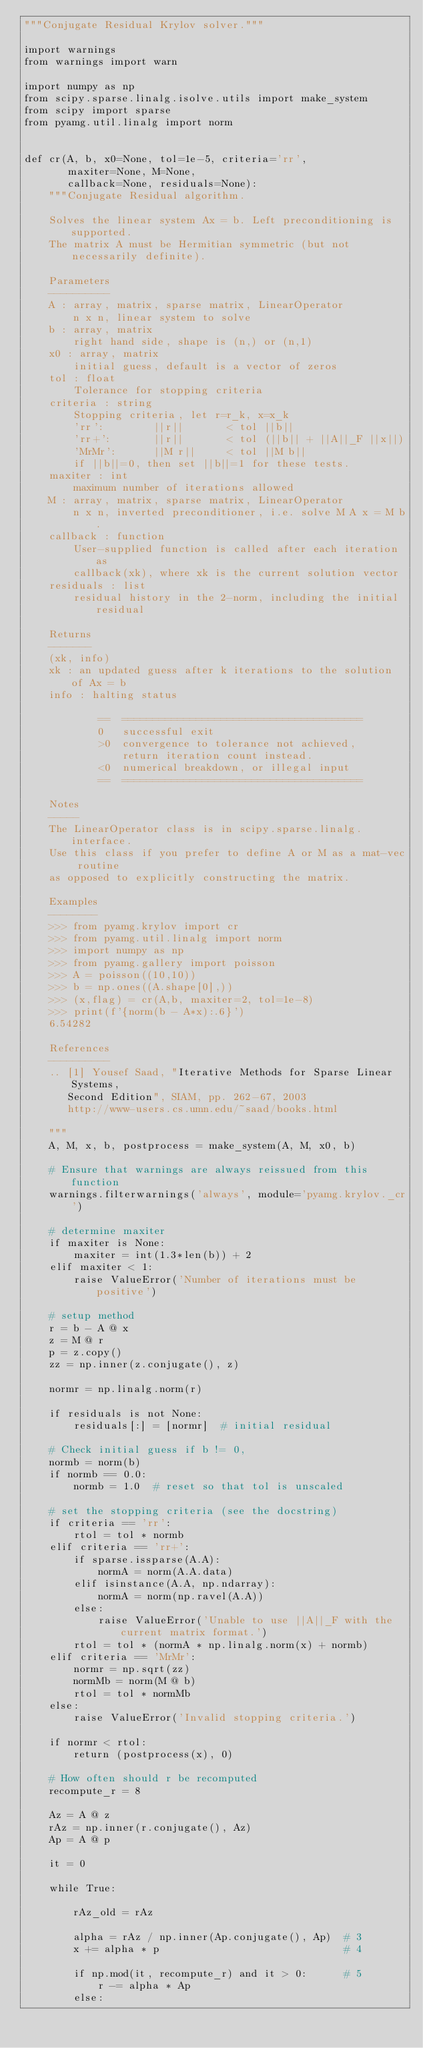Convert code to text. <code><loc_0><loc_0><loc_500><loc_500><_Python_>"""Conjugate Residual Krylov solver."""

import warnings
from warnings import warn

import numpy as np
from scipy.sparse.linalg.isolve.utils import make_system
from scipy import sparse
from pyamg.util.linalg import norm


def cr(A, b, x0=None, tol=1e-5, criteria='rr',
       maxiter=None, M=None,
       callback=None, residuals=None):
    """Conjugate Residual algorithm.

    Solves the linear system Ax = b. Left preconditioning is supported.
    The matrix A must be Hermitian symmetric (but not necessarily definite).

    Parameters
    ----------
    A : array, matrix, sparse matrix, LinearOperator
        n x n, linear system to solve
    b : array, matrix
        right hand side, shape is (n,) or (n,1)
    x0 : array, matrix
        initial guess, default is a vector of zeros
    tol : float
        Tolerance for stopping criteria
    criteria : string
        Stopping criteria, let r=r_k, x=x_k
        'rr':        ||r||       < tol ||b||
        'rr+':       ||r||       < tol (||b|| + ||A||_F ||x||)
        'MrMr':      ||M r||     < tol ||M b||
        if ||b||=0, then set ||b||=1 for these tests.
    maxiter : int
        maximum number of iterations allowed
    M : array, matrix, sparse matrix, LinearOperator
        n x n, inverted preconditioner, i.e. solve M A x = M b.
    callback : function
        User-supplied function is called after each iteration as
        callback(xk), where xk is the current solution vector
    residuals : list
        residual history in the 2-norm, including the initial residual

    Returns
    -------
    (xk, info)
    xk : an updated guess after k iterations to the solution of Ax = b
    info : halting status

            ==  =======================================
            0   successful exit
            >0  convergence to tolerance not achieved,
                return iteration count instead.
            <0  numerical breakdown, or illegal input
            ==  =======================================

    Notes
    -----
    The LinearOperator class is in scipy.sparse.linalg.interface.
    Use this class if you prefer to define A or M as a mat-vec routine
    as opposed to explicitly constructing the matrix.

    Examples
    --------
    >>> from pyamg.krylov import cr
    >>> from pyamg.util.linalg import norm
    >>> import numpy as np
    >>> from pyamg.gallery import poisson
    >>> A = poisson((10,10))
    >>> b = np.ones((A.shape[0],))
    >>> (x,flag) = cr(A,b, maxiter=2, tol=1e-8)
    >>> print(f'{norm(b - A*x):.6}')
    6.54282

    References
    ----------
    .. [1] Yousef Saad, "Iterative Methods for Sparse Linear Systems,
       Second Edition", SIAM, pp. 262-67, 2003
       http://www-users.cs.umn.edu/~saad/books.html

    """
    A, M, x, b, postprocess = make_system(A, M, x0, b)

    # Ensure that warnings are always reissued from this function
    warnings.filterwarnings('always', module='pyamg.krylov._cr')

    # determine maxiter
    if maxiter is None:
        maxiter = int(1.3*len(b)) + 2
    elif maxiter < 1:
        raise ValueError('Number of iterations must be positive')

    # setup method
    r = b - A @ x
    z = M @ r
    p = z.copy()
    zz = np.inner(z.conjugate(), z)

    normr = np.linalg.norm(r)

    if residuals is not None:
        residuals[:] = [normr]  # initial residual

    # Check initial guess if b != 0,
    normb = norm(b)
    if normb == 0.0:
        normb = 1.0  # reset so that tol is unscaled

    # set the stopping criteria (see the docstring)
    if criteria == 'rr':
        rtol = tol * normb
    elif criteria == 'rr+':
        if sparse.issparse(A.A):
            normA = norm(A.A.data)
        elif isinstance(A.A, np.ndarray):
            normA = norm(np.ravel(A.A))
        else:
            raise ValueError('Unable to use ||A||_F with the current matrix format.')
        rtol = tol * (normA * np.linalg.norm(x) + normb)
    elif criteria == 'MrMr':
        normr = np.sqrt(zz)
        normMb = norm(M @ b)
        rtol = tol * normMb
    else:
        raise ValueError('Invalid stopping criteria.')

    if normr < rtol:
        return (postprocess(x), 0)

    # How often should r be recomputed
    recompute_r = 8

    Az = A @ z
    rAz = np.inner(r.conjugate(), Az)
    Ap = A @ p

    it = 0

    while True:

        rAz_old = rAz

        alpha = rAz / np.inner(Ap.conjugate(), Ap)  # 3
        x += alpha * p                              # 4

        if np.mod(it, recompute_r) and it > 0:      # 5
            r -= alpha * Ap
        else:</code> 